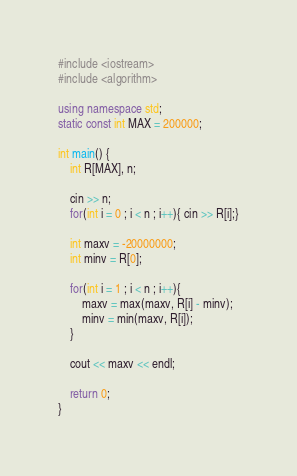Convert code to text. <code><loc_0><loc_0><loc_500><loc_500><_C++_>#include <iostream>
#include <algorithm>

using namespace std;
static const int MAX = 200000;

int main() {
	int R[MAX], n;
	
	cin >> n;
	for(int i = 0 ; i < n ; i++){ cin >> R[i];}
	
	int maxv = -20000000;
	int minv = R[0];
	
	for(int i = 1 ; i < n ; i++){
		maxv = max(maxv, R[i] - minv);
		minv = min(maxv, R[i]);
	}
	
	cout << maxv << endl;
	
	return 0;
}</code> 